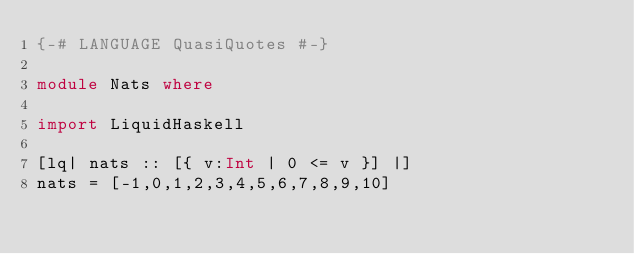<code> <loc_0><loc_0><loc_500><loc_500><_Haskell_>{-# LANGUAGE QuasiQuotes #-}

module Nats where

import LiquidHaskell

[lq| nats :: [{ v:Int | 0 <= v }] |]
nats = [-1,0,1,2,3,4,5,6,7,8,9,10]

</code> 